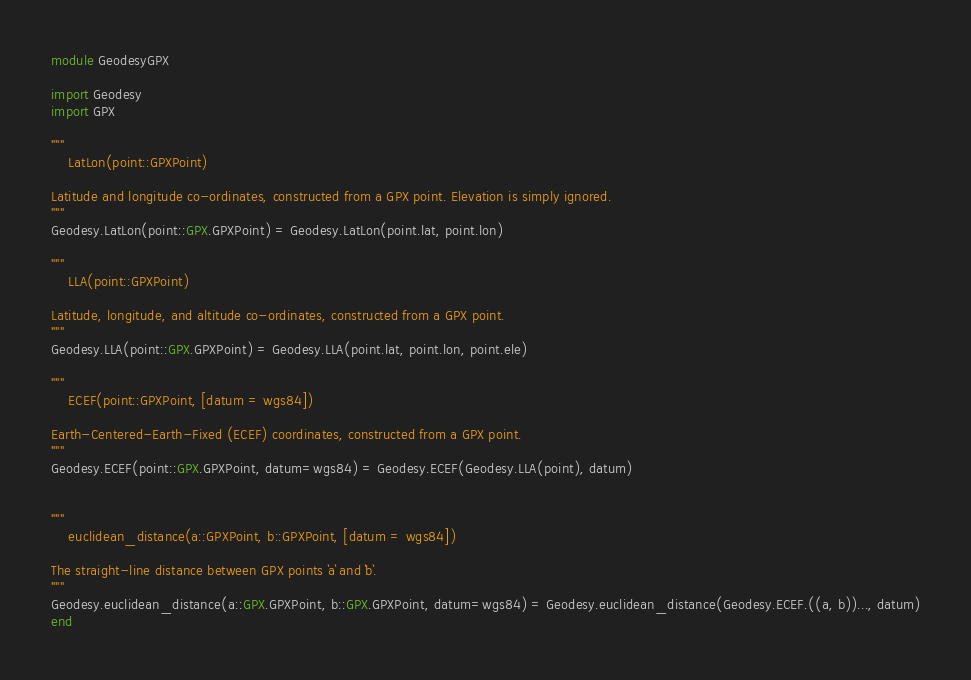<code> <loc_0><loc_0><loc_500><loc_500><_Julia_>module GeodesyGPX

import Geodesy
import GPX

"""
    LatLon(point::GPXPoint)

Latitude and longitude co-ordinates, constructed from a GPX point. Elevation is simply ignored.
"""
Geodesy.LatLon(point::GPX.GPXPoint) = Geodesy.LatLon(point.lat, point.lon)

"""
    LLA(point::GPXPoint)

Latitude, longitude, and altitude co-ordinates, constructed from a GPX point.
"""
Geodesy.LLA(point::GPX.GPXPoint) = Geodesy.LLA(point.lat, point.lon, point.ele)

"""
	ECEF(point::GPXPoint, [datum = wgs84])

Earth-Centered-Earth-Fixed (ECEF) coordinates, constructed from a GPX point.
"""
Geodesy.ECEF(point::GPX.GPXPoint, datum=wgs84) = Geodesy.ECEF(Geodesy.LLA(point), datum)


"""
    euclidean_distance(a::GPXPoint, b::GPXPoint, [datum = wgs84])

The straight-line distance between GPX points `a` and `b`.
"""
Geodesy.euclidean_distance(a::GPX.GPXPoint, b::GPX.GPXPoint, datum=wgs84) = Geodesy.euclidean_distance(Geodesy.ECEF.((a, b))..., datum)
end
</code> 